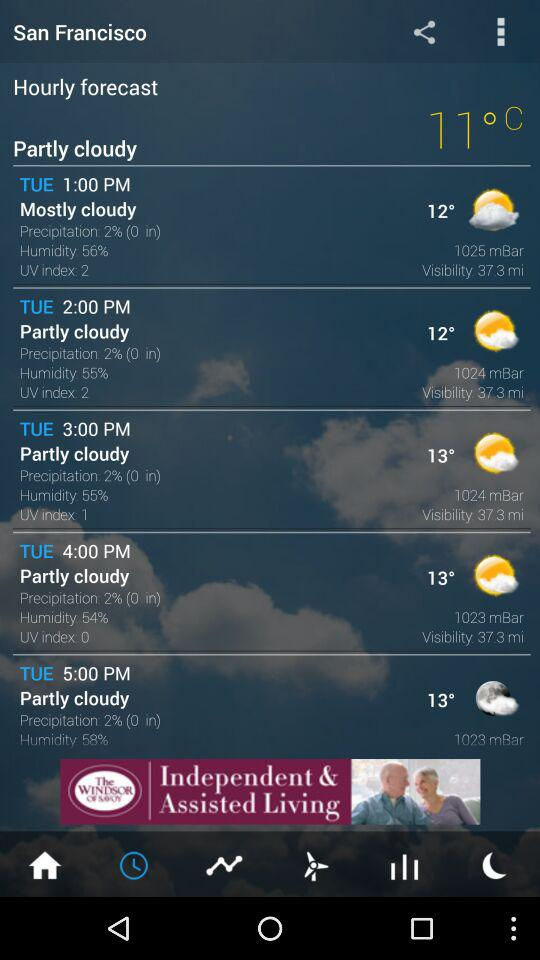What is the weather forecast for Tuesday at 2:00 PM? The weather forecast is "Partly cloudy". 